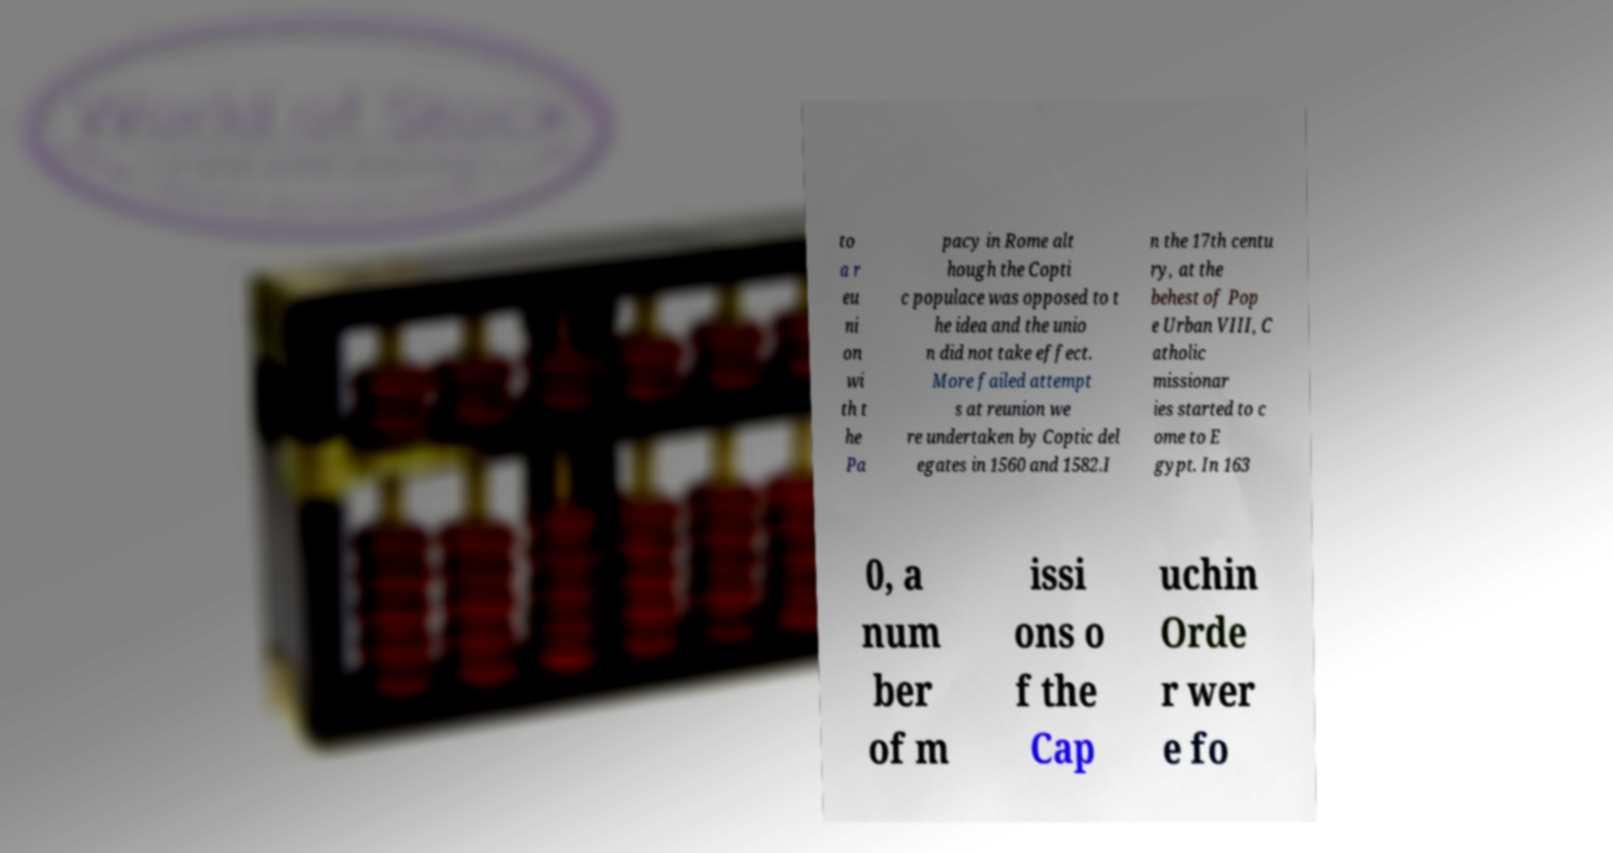For documentation purposes, I need the text within this image transcribed. Could you provide that? to a r eu ni on wi th t he Pa pacy in Rome alt hough the Copti c populace was opposed to t he idea and the unio n did not take effect. More failed attempt s at reunion we re undertaken by Coptic del egates in 1560 and 1582.I n the 17th centu ry, at the behest of Pop e Urban VIII, C atholic missionar ies started to c ome to E gypt. In 163 0, a num ber of m issi ons o f the Cap uchin Orde r wer e fo 